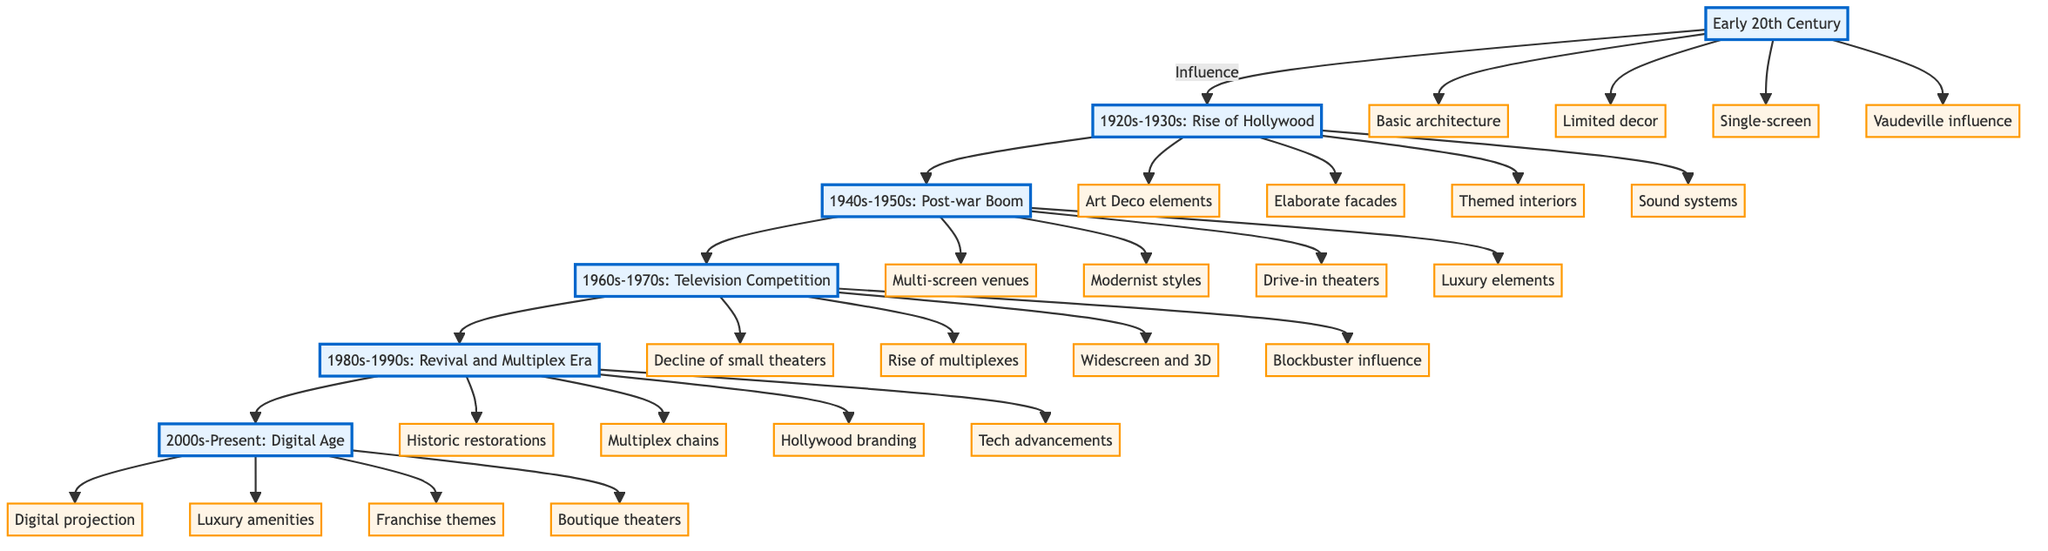What is the first period shown in the diagram? The diagram shows "Early 20th Century" as the first period, which is connected to the subsequent period, indicating its position within the overall timeline of theater architecture.
Answer: Early 20th Century How many architectural factors are listed for the 1940s-1950s: Post-war Boom period? The 1940s-1950s period has four factors associated with it, confirming a trend towards larger and more luxurious designs during that time and showing how Hollywood influence manifested in theaters.
Answer: 4 What influence drove the decline of small-town theaters in the 1960s-1970s? The diagram highlights "Rise of multiplexes" as a key factor that drove the decline, illustrating how changing entertainment options affected the traditional small-town theater model.
Answer: Rise of multiplexes Which architectural style was introduced in the 1920s-1930s? The factor "Art Deco elements" signifies that this was a prominent style during the Rise of Hollywood, showcasing how Hollywood fashions were incorporated into small-town theater designs at that time.
Answer: Art Deco elements How are the 1980s-1990s theaters described in relation to Hollywood? The term "Hollywood branding" suggests that theaters during this time embraced a closer association with Hollywood aesthetics, indicating a way to attract moviegoers amidst competition from other entertainment sources.
Answer: Hollywood branding What is the most recent period depicted in the diagram? The most recent period, "2000s-Present: Digital Age," reflects the latest trends and technological changes influencing theater architecture, showing the evolution's endpoint as depicted in the flow of the diagram.
Answer: 2000s-Present: Digital Age How did the introduction of sound systems change the theater experience in the 1920s-1930s? The factor of "Sound systems" reflects a significant technological advance that allowed films to have audio, enhancing the cinematic experience based on Hollywood innovations during this influential era.
Answer: Sound systems What is a key feature of theaters in the 2000s-Present era? "Luxury amenities" captures a trend that reflects the modern audience's expectations, indicating how theaters adopted upscale features to compete with other entertainment venues.
Answer: Luxury amenities What marked the transition from single-screen theaters in the early 20th century? The transition is marked by "Multi-screen venues" introduced in the 1940s-1950s, showcasing the evolution from simpler designs to modern theaters that offer more viewing options in line with changing audience demands.
Answer: Multi-screen venues 